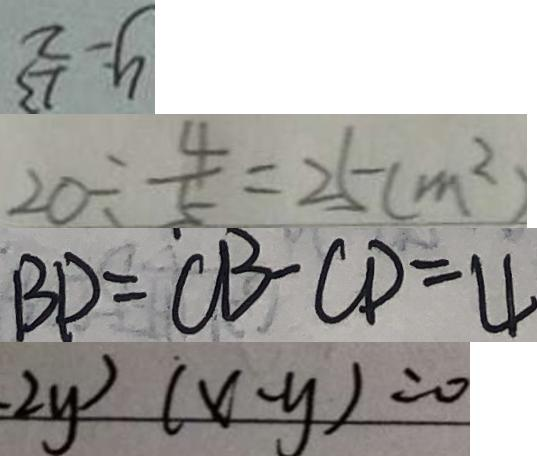Convert formula to latex. <formula><loc_0><loc_0><loc_500><loc_500>y = \frac { 1 3 } { 2 } 
 2 0 \div \frac { 4 } { 5 } = 2 5 ( m ^ { 2 } ) 
 B D = C B - C D = 4 
 - 2 y ) ( x - y ) = 0</formula> 